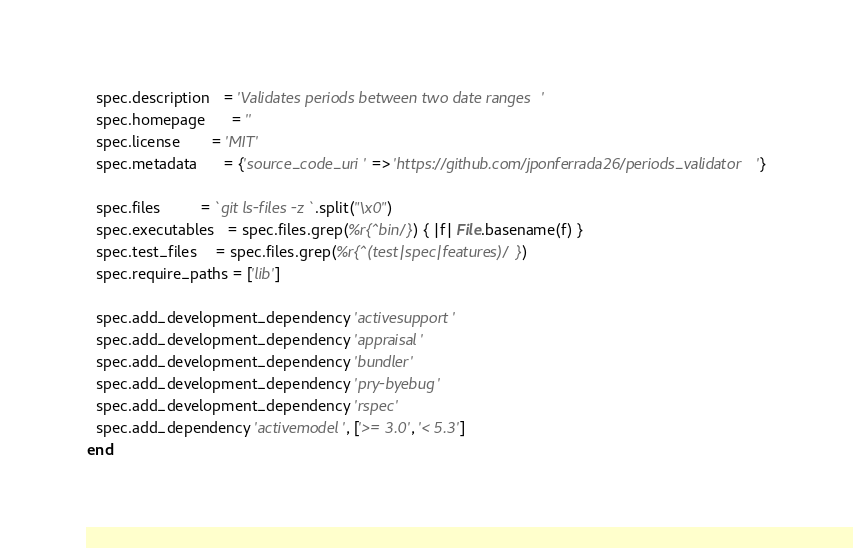<code> <loc_0><loc_0><loc_500><loc_500><_Ruby_>  spec.description   = 'Validates periods between two date ranges'
  spec.homepage      = ''
  spec.license       = 'MIT'
  spec.metadata      = {'source_code_uri' => 'https://github.com/jponferrada26/periods_validator'}

  spec.files         = `git ls-files -z`.split("\x0")
  spec.executables   = spec.files.grep(%r{^bin/}) { |f| File.basename(f) }
  spec.test_files    = spec.files.grep(%r{^(test|spec|features)/})
  spec.require_paths = ['lib']

  spec.add_development_dependency 'activesupport'
  spec.add_development_dependency 'appraisal'
  spec.add_development_dependency 'bundler'
  spec.add_development_dependency 'pry-byebug'
  spec.add_development_dependency 'rspec'
  spec.add_dependency 'activemodel', ['>= 3.0', '< 5.3']
end
</code> 